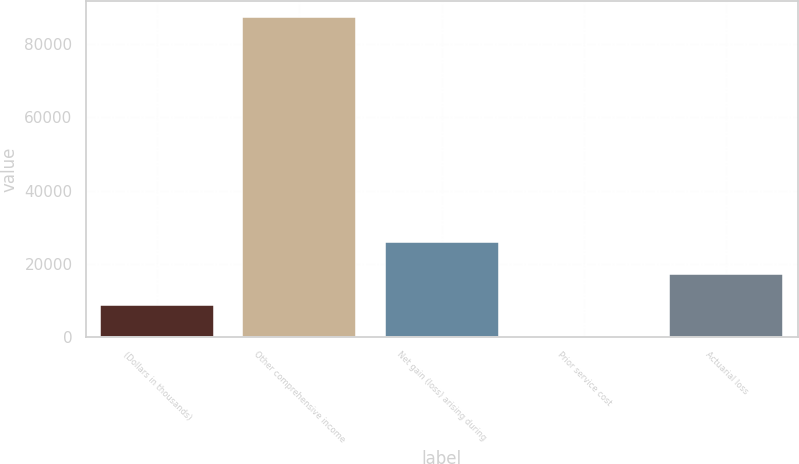Convert chart to OTSL. <chart><loc_0><loc_0><loc_500><loc_500><bar_chart><fcel>(Dollars in thousands)<fcel>Other comprehensive income<fcel>Net gain (loss) arising during<fcel>Prior service cost<fcel>Actuarial loss<nl><fcel>8638<fcel>87512<fcel>25816<fcel>49<fcel>17227<nl></chart> 